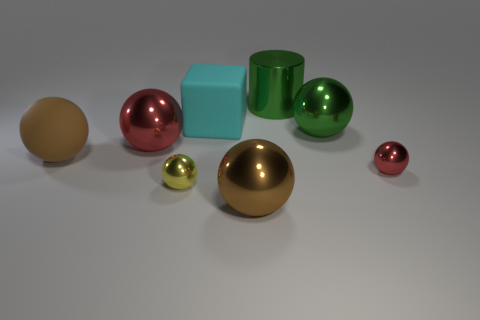How many other spheres have the same color as the rubber sphere?
Your answer should be very brief. 1. Does the metallic cylinder have the same color as the big metallic object to the right of the cylinder?
Offer a terse response. Yes. Do the large cylinder and the large green ball have the same material?
Provide a succinct answer. Yes. There is a metallic object that is the same color as the rubber sphere; what size is it?
Your answer should be very brief. Large. Are there any spheres of the same color as the big shiny cylinder?
Ensure brevity in your answer.  Yes. What size is the brown ball that is the same material as the big cyan block?
Your answer should be very brief. Large. What is the shape of the brown object that is to the right of the large brown object that is left of the tiny yellow object in front of the large red object?
Your answer should be very brief. Sphere. What size is the green thing that is the same shape as the brown rubber thing?
Offer a very short reply. Large. How big is the shiny thing that is in front of the big red metal object and behind the yellow sphere?
Your response must be concise. Small. What is the shape of the shiny thing that is the same color as the metallic cylinder?
Your answer should be compact. Sphere. 